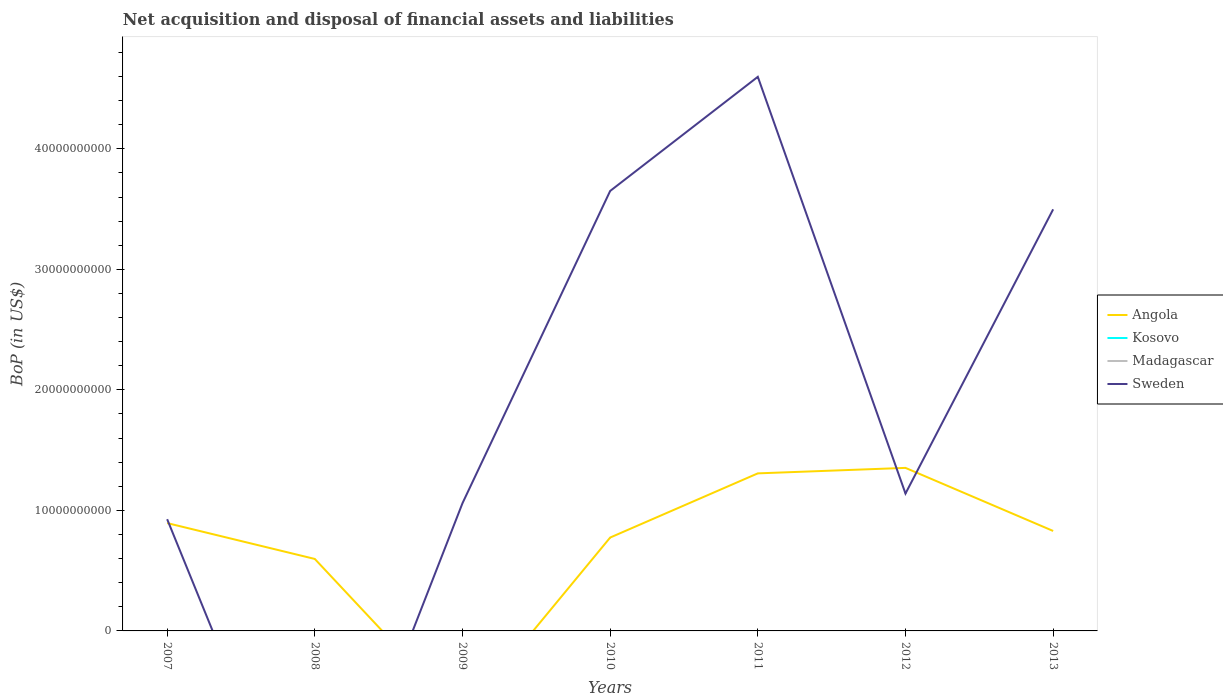Is the number of lines equal to the number of legend labels?
Offer a very short reply. No. What is the total Balance of Payments in Angola in the graph?
Offer a terse response. -4.55e+08. What is the difference between the highest and the second highest Balance of Payments in Angola?
Provide a short and direct response. 1.35e+1. How many years are there in the graph?
Keep it short and to the point. 7. What is the difference between two consecutive major ticks on the Y-axis?
Offer a terse response. 1.00e+1. Does the graph contain grids?
Your response must be concise. No. Where does the legend appear in the graph?
Offer a terse response. Center right. How many legend labels are there?
Your answer should be very brief. 4. How are the legend labels stacked?
Keep it short and to the point. Vertical. What is the title of the graph?
Make the answer very short. Net acquisition and disposal of financial assets and liabilities. Does "Oman" appear as one of the legend labels in the graph?
Your answer should be very brief. No. What is the label or title of the X-axis?
Provide a succinct answer. Years. What is the label or title of the Y-axis?
Keep it short and to the point. BoP (in US$). What is the BoP (in US$) in Angola in 2007?
Make the answer very short. 8.95e+09. What is the BoP (in US$) of Sweden in 2007?
Your response must be concise. 9.27e+09. What is the BoP (in US$) in Angola in 2008?
Your answer should be compact. 5.97e+09. What is the BoP (in US$) in Kosovo in 2008?
Offer a terse response. 0. What is the BoP (in US$) of Angola in 2009?
Your answer should be very brief. 0. What is the BoP (in US$) of Kosovo in 2009?
Your answer should be compact. 0. What is the BoP (in US$) of Sweden in 2009?
Provide a succinct answer. 1.06e+1. What is the BoP (in US$) of Angola in 2010?
Offer a terse response. 7.75e+09. What is the BoP (in US$) in Madagascar in 2010?
Ensure brevity in your answer.  0. What is the BoP (in US$) of Sweden in 2010?
Ensure brevity in your answer.  3.65e+1. What is the BoP (in US$) of Angola in 2011?
Offer a terse response. 1.31e+1. What is the BoP (in US$) in Sweden in 2011?
Offer a terse response. 4.60e+1. What is the BoP (in US$) of Angola in 2012?
Your answer should be very brief. 1.35e+1. What is the BoP (in US$) of Kosovo in 2012?
Your response must be concise. 0. What is the BoP (in US$) of Sweden in 2012?
Ensure brevity in your answer.  1.14e+1. What is the BoP (in US$) of Angola in 2013?
Provide a succinct answer. 8.29e+09. What is the BoP (in US$) of Sweden in 2013?
Offer a terse response. 3.50e+1. Across all years, what is the maximum BoP (in US$) in Angola?
Provide a succinct answer. 1.35e+1. Across all years, what is the maximum BoP (in US$) of Sweden?
Provide a short and direct response. 4.60e+1. Across all years, what is the minimum BoP (in US$) in Sweden?
Your answer should be compact. 0. What is the total BoP (in US$) in Angola in the graph?
Ensure brevity in your answer.  5.76e+1. What is the total BoP (in US$) in Madagascar in the graph?
Ensure brevity in your answer.  0. What is the total BoP (in US$) of Sweden in the graph?
Your answer should be very brief. 1.49e+11. What is the difference between the BoP (in US$) of Angola in 2007 and that in 2008?
Offer a terse response. 2.98e+09. What is the difference between the BoP (in US$) in Sweden in 2007 and that in 2009?
Make the answer very short. -1.33e+09. What is the difference between the BoP (in US$) in Angola in 2007 and that in 2010?
Make the answer very short. 1.20e+09. What is the difference between the BoP (in US$) in Sweden in 2007 and that in 2010?
Make the answer very short. -2.72e+1. What is the difference between the BoP (in US$) of Angola in 2007 and that in 2011?
Give a very brief answer. -4.13e+09. What is the difference between the BoP (in US$) in Sweden in 2007 and that in 2011?
Offer a very short reply. -3.67e+1. What is the difference between the BoP (in US$) of Angola in 2007 and that in 2012?
Your answer should be very brief. -4.58e+09. What is the difference between the BoP (in US$) of Sweden in 2007 and that in 2012?
Offer a very short reply. -2.13e+09. What is the difference between the BoP (in US$) of Angola in 2007 and that in 2013?
Offer a very short reply. 6.54e+08. What is the difference between the BoP (in US$) in Sweden in 2007 and that in 2013?
Give a very brief answer. -2.57e+1. What is the difference between the BoP (in US$) in Angola in 2008 and that in 2010?
Your answer should be very brief. -1.78e+09. What is the difference between the BoP (in US$) of Angola in 2008 and that in 2011?
Provide a short and direct response. -7.10e+09. What is the difference between the BoP (in US$) of Angola in 2008 and that in 2012?
Ensure brevity in your answer.  -7.56e+09. What is the difference between the BoP (in US$) in Angola in 2008 and that in 2013?
Provide a succinct answer. -2.32e+09. What is the difference between the BoP (in US$) in Sweden in 2009 and that in 2010?
Your response must be concise. -2.59e+1. What is the difference between the BoP (in US$) of Sweden in 2009 and that in 2011?
Your answer should be compact. -3.54e+1. What is the difference between the BoP (in US$) in Sweden in 2009 and that in 2012?
Your response must be concise. -8.00e+08. What is the difference between the BoP (in US$) of Sweden in 2009 and that in 2013?
Your answer should be compact. -2.44e+1. What is the difference between the BoP (in US$) in Angola in 2010 and that in 2011?
Your response must be concise. -5.33e+09. What is the difference between the BoP (in US$) of Sweden in 2010 and that in 2011?
Your response must be concise. -9.47e+09. What is the difference between the BoP (in US$) in Angola in 2010 and that in 2012?
Keep it short and to the point. -5.78e+09. What is the difference between the BoP (in US$) of Sweden in 2010 and that in 2012?
Your answer should be very brief. 2.51e+1. What is the difference between the BoP (in US$) in Angola in 2010 and that in 2013?
Make the answer very short. -5.47e+08. What is the difference between the BoP (in US$) in Sweden in 2010 and that in 2013?
Your answer should be compact. 1.52e+09. What is the difference between the BoP (in US$) in Angola in 2011 and that in 2012?
Provide a short and direct response. -4.55e+08. What is the difference between the BoP (in US$) in Sweden in 2011 and that in 2012?
Keep it short and to the point. 3.46e+1. What is the difference between the BoP (in US$) of Angola in 2011 and that in 2013?
Give a very brief answer. 4.78e+09. What is the difference between the BoP (in US$) of Sweden in 2011 and that in 2013?
Ensure brevity in your answer.  1.10e+1. What is the difference between the BoP (in US$) of Angola in 2012 and that in 2013?
Your response must be concise. 5.23e+09. What is the difference between the BoP (in US$) in Sweden in 2012 and that in 2013?
Provide a succinct answer. -2.36e+1. What is the difference between the BoP (in US$) of Angola in 2007 and the BoP (in US$) of Sweden in 2009?
Offer a terse response. -1.65e+09. What is the difference between the BoP (in US$) in Angola in 2007 and the BoP (in US$) in Sweden in 2010?
Your response must be concise. -2.76e+1. What is the difference between the BoP (in US$) in Angola in 2007 and the BoP (in US$) in Sweden in 2011?
Your answer should be compact. -3.70e+1. What is the difference between the BoP (in US$) in Angola in 2007 and the BoP (in US$) in Sweden in 2012?
Give a very brief answer. -2.45e+09. What is the difference between the BoP (in US$) of Angola in 2007 and the BoP (in US$) of Sweden in 2013?
Ensure brevity in your answer.  -2.60e+1. What is the difference between the BoP (in US$) of Angola in 2008 and the BoP (in US$) of Sweden in 2009?
Offer a terse response. -4.63e+09. What is the difference between the BoP (in US$) of Angola in 2008 and the BoP (in US$) of Sweden in 2010?
Your answer should be very brief. -3.05e+1. What is the difference between the BoP (in US$) of Angola in 2008 and the BoP (in US$) of Sweden in 2011?
Offer a terse response. -4.00e+1. What is the difference between the BoP (in US$) in Angola in 2008 and the BoP (in US$) in Sweden in 2012?
Make the answer very short. -5.43e+09. What is the difference between the BoP (in US$) in Angola in 2008 and the BoP (in US$) in Sweden in 2013?
Provide a short and direct response. -2.90e+1. What is the difference between the BoP (in US$) of Angola in 2010 and the BoP (in US$) of Sweden in 2011?
Offer a very short reply. -3.82e+1. What is the difference between the BoP (in US$) in Angola in 2010 and the BoP (in US$) in Sweden in 2012?
Make the answer very short. -3.65e+09. What is the difference between the BoP (in US$) in Angola in 2010 and the BoP (in US$) in Sweden in 2013?
Your answer should be compact. -2.72e+1. What is the difference between the BoP (in US$) in Angola in 2011 and the BoP (in US$) in Sweden in 2012?
Your response must be concise. 1.68e+09. What is the difference between the BoP (in US$) in Angola in 2011 and the BoP (in US$) in Sweden in 2013?
Ensure brevity in your answer.  -2.19e+1. What is the difference between the BoP (in US$) of Angola in 2012 and the BoP (in US$) of Sweden in 2013?
Ensure brevity in your answer.  -2.15e+1. What is the average BoP (in US$) in Angola per year?
Offer a terse response. 8.22e+09. What is the average BoP (in US$) of Sweden per year?
Provide a short and direct response. 2.12e+1. In the year 2007, what is the difference between the BoP (in US$) of Angola and BoP (in US$) of Sweden?
Offer a very short reply. -3.23e+08. In the year 2010, what is the difference between the BoP (in US$) of Angola and BoP (in US$) of Sweden?
Provide a short and direct response. -2.88e+1. In the year 2011, what is the difference between the BoP (in US$) of Angola and BoP (in US$) of Sweden?
Make the answer very short. -3.29e+1. In the year 2012, what is the difference between the BoP (in US$) of Angola and BoP (in US$) of Sweden?
Ensure brevity in your answer.  2.13e+09. In the year 2013, what is the difference between the BoP (in US$) of Angola and BoP (in US$) of Sweden?
Give a very brief answer. -2.67e+1. What is the ratio of the BoP (in US$) of Angola in 2007 to that in 2008?
Provide a short and direct response. 1.5. What is the ratio of the BoP (in US$) in Sweden in 2007 to that in 2009?
Make the answer very short. 0.87. What is the ratio of the BoP (in US$) in Angola in 2007 to that in 2010?
Provide a short and direct response. 1.16. What is the ratio of the BoP (in US$) in Sweden in 2007 to that in 2010?
Your answer should be very brief. 0.25. What is the ratio of the BoP (in US$) in Angola in 2007 to that in 2011?
Keep it short and to the point. 0.68. What is the ratio of the BoP (in US$) in Sweden in 2007 to that in 2011?
Offer a very short reply. 0.2. What is the ratio of the BoP (in US$) of Angola in 2007 to that in 2012?
Give a very brief answer. 0.66. What is the ratio of the BoP (in US$) in Sweden in 2007 to that in 2012?
Your answer should be compact. 0.81. What is the ratio of the BoP (in US$) of Angola in 2007 to that in 2013?
Make the answer very short. 1.08. What is the ratio of the BoP (in US$) in Sweden in 2007 to that in 2013?
Your response must be concise. 0.27. What is the ratio of the BoP (in US$) of Angola in 2008 to that in 2010?
Provide a succinct answer. 0.77. What is the ratio of the BoP (in US$) in Angola in 2008 to that in 2011?
Keep it short and to the point. 0.46. What is the ratio of the BoP (in US$) in Angola in 2008 to that in 2012?
Give a very brief answer. 0.44. What is the ratio of the BoP (in US$) in Angola in 2008 to that in 2013?
Provide a short and direct response. 0.72. What is the ratio of the BoP (in US$) in Sweden in 2009 to that in 2010?
Offer a terse response. 0.29. What is the ratio of the BoP (in US$) in Sweden in 2009 to that in 2011?
Make the answer very short. 0.23. What is the ratio of the BoP (in US$) in Sweden in 2009 to that in 2012?
Keep it short and to the point. 0.93. What is the ratio of the BoP (in US$) of Sweden in 2009 to that in 2013?
Offer a very short reply. 0.3. What is the ratio of the BoP (in US$) in Angola in 2010 to that in 2011?
Your answer should be very brief. 0.59. What is the ratio of the BoP (in US$) of Sweden in 2010 to that in 2011?
Provide a succinct answer. 0.79. What is the ratio of the BoP (in US$) of Angola in 2010 to that in 2012?
Your answer should be compact. 0.57. What is the ratio of the BoP (in US$) in Sweden in 2010 to that in 2012?
Your answer should be very brief. 3.2. What is the ratio of the BoP (in US$) in Angola in 2010 to that in 2013?
Give a very brief answer. 0.93. What is the ratio of the BoP (in US$) of Sweden in 2010 to that in 2013?
Keep it short and to the point. 1.04. What is the ratio of the BoP (in US$) in Angola in 2011 to that in 2012?
Provide a short and direct response. 0.97. What is the ratio of the BoP (in US$) in Sweden in 2011 to that in 2012?
Your response must be concise. 4.03. What is the ratio of the BoP (in US$) of Angola in 2011 to that in 2013?
Make the answer very short. 1.58. What is the ratio of the BoP (in US$) of Sweden in 2011 to that in 2013?
Provide a short and direct response. 1.31. What is the ratio of the BoP (in US$) in Angola in 2012 to that in 2013?
Provide a succinct answer. 1.63. What is the ratio of the BoP (in US$) in Sweden in 2012 to that in 2013?
Ensure brevity in your answer.  0.33. What is the difference between the highest and the second highest BoP (in US$) of Angola?
Offer a terse response. 4.55e+08. What is the difference between the highest and the second highest BoP (in US$) of Sweden?
Offer a terse response. 9.47e+09. What is the difference between the highest and the lowest BoP (in US$) of Angola?
Give a very brief answer. 1.35e+1. What is the difference between the highest and the lowest BoP (in US$) of Sweden?
Offer a terse response. 4.60e+1. 